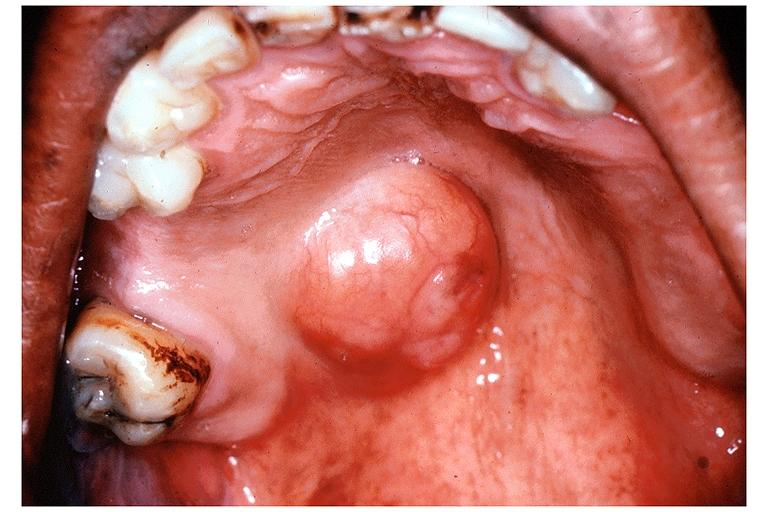what does this image show?
Answer the question using a single word or phrase. Pleomorphic adenoma benign mixed tumor 